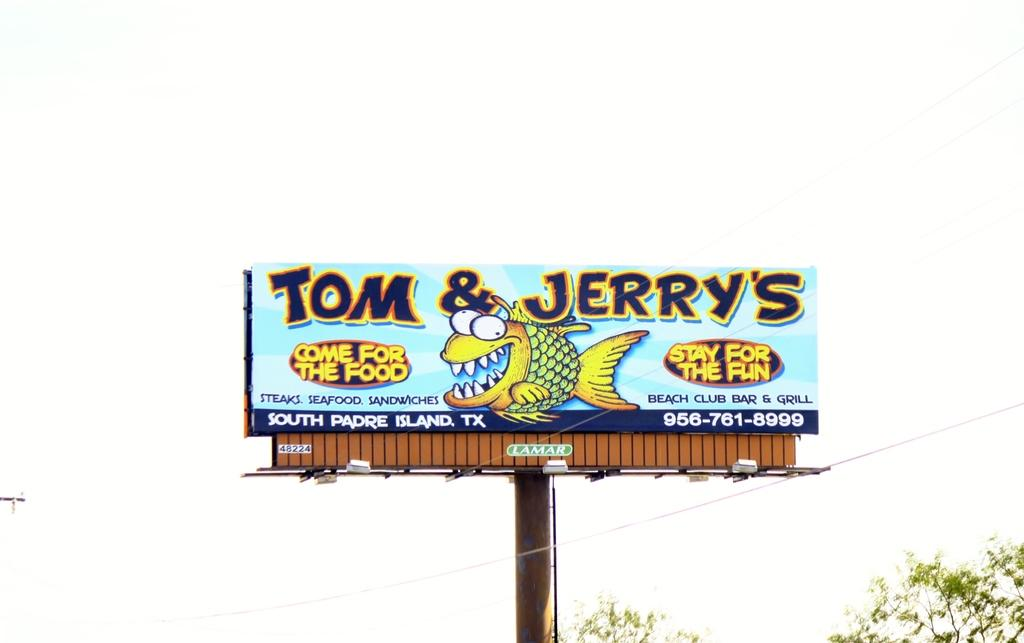<image>
Write a terse but informative summary of the picture. A billboard for Tom and Jerry's promises food and fun to its prospective patrons. 